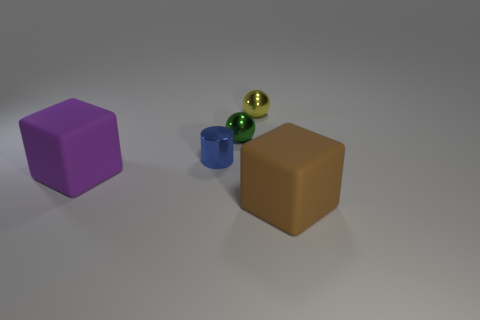Add 5 tiny green shiny things. How many objects exist? 10 Subtract 1 cylinders. How many cylinders are left? 0 Subtract 1 blue cylinders. How many objects are left? 4 Subtract all cubes. How many objects are left? 3 Subtract all brown cubes. Subtract all brown cylinders. How many cubes are left? 1 Subtract all tiny green spheres. Subtract all tiny objects. How many objects are left? 1 Add 3 big purple objects. How many big purple objects are left? 4 Add 5 big brown shiny cylinders. How many big brown shiny cylinders exist? 5 